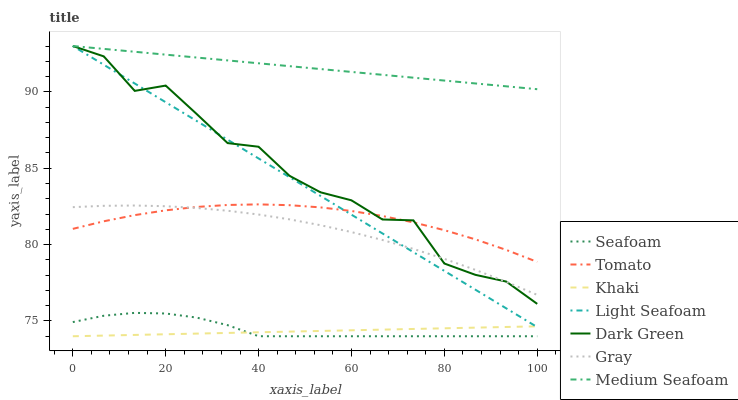Does Khaki have the minimum area under the curve?
Answer yes or no. Yes. Does Medium Seafoam have the maximum area under the curve?
Answer yes or no. Yes. Does Gray have the minimum area under the curve?
Answer yes or no. No. Does Gray have the maximum area under the curve?
Answer yes or no. No. Is Medium Seafoam the smoothest?
Answer yes or no. Yes. Is Dark Green the roughest?
Answer yes or no. Yes. Is Gray the smoothest?
Answer yes or no. No. Is Gray the roughest?
Answer yes or no. No. Does Gray have the lowest value?
Answer yes or no. No. Does Gray have the highest value?
Answer yes or no. No. Is Khaki less than Tomato?
Answer yes or no. Yes. Is Light Seafoam greater than Seafoam?
Answer yes or no. Yes. Does Khaki intersect Tomato?
Answer yes or no. No. 